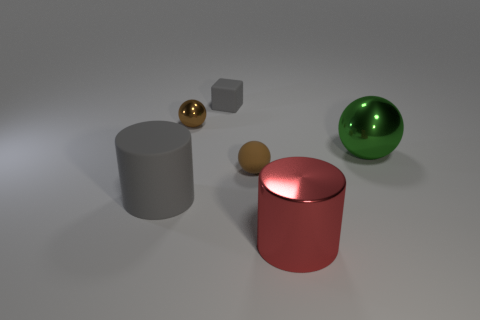There is a brown object that is to the right of the small gray thing that is behind the big green metal ball; how many matte cubes are behind it?
Make the answer very short. 1. Do the gray matte thing behind the tiny brown rubber thing and the gray rubber object that is on the left side of the small brown shiny ball have the same size?
Your response must be concise. No. There is a large cylinder left of the big cylinder on the right side of the large matte cylinder; what is its material?
Ensure brevity in your answer.  Rubber. How many objects are small gray things behind the big green object or green metal cubes?
Provide a succinct answer. 1. Are there an equal number of gray cubes that are behind the small gray rubber cube and large gray matte objects that are on the left side of the gray rubber cylinder?
Your answer should be compact. Yes. What material is the small object that is in front of the metallic ball that is to the right of the large shiny object on the left side of the large ball made of?
Provide a short and direct response. Rubber. There is a matte thing that is behind the large matte thing and in front of the green shiny object; what size is it?
Provide a short and direct response. Small. Does the brown metallic object have the same shape as the green metal object?
Offer a terse response. Yes. There is a small brown thing that is made of the same material as the large green sphere; what shape is it?
Keep it short and to the point. Sphere. How many small things are brown metallic things or gray rubber blocks?
Provide a short and direct response. 2. 